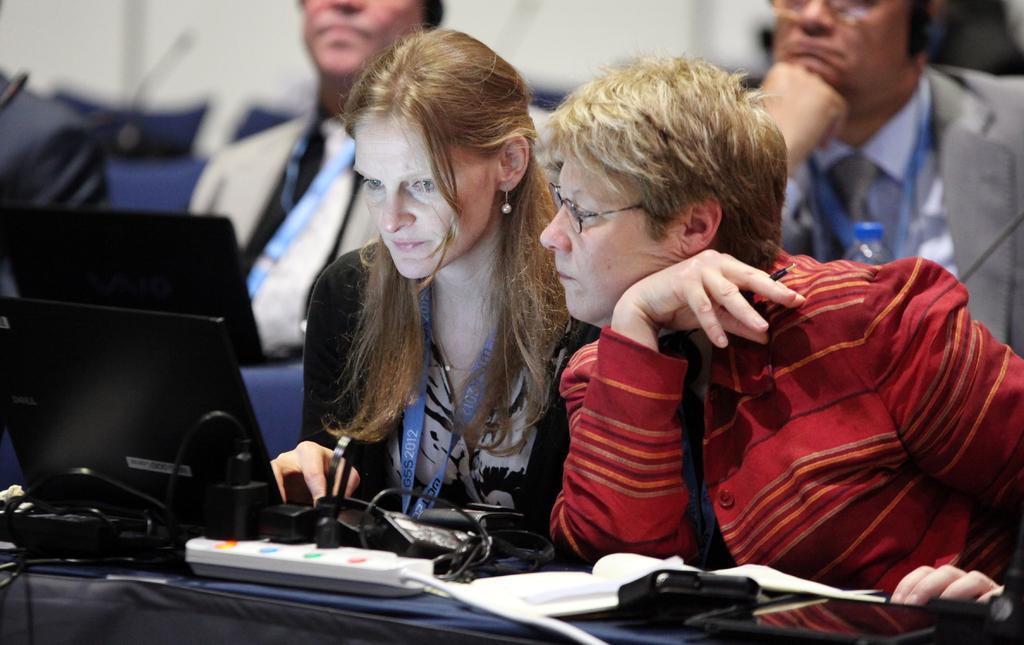Describe this image in one or two sentences. In this picture I can see there are two women sitting on the chairs and the women at the right side is wearing spectacles, the woman next to her is wearing an ID card and there are few men sitting behind her, there is a water bottle at the right side. In the backdrop there is a wall and the backdrop of the image is blurred. 